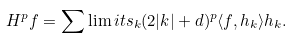Convert formula to latex. <formula><loc_0><loc_0><loc_500><loc_500>H ^ { p } f = \sum \lim i t s _ { k } ( 2 | k | + d ) ^ { p } \langle f , h _ { k } \rangle h _ { k } .</formula> 